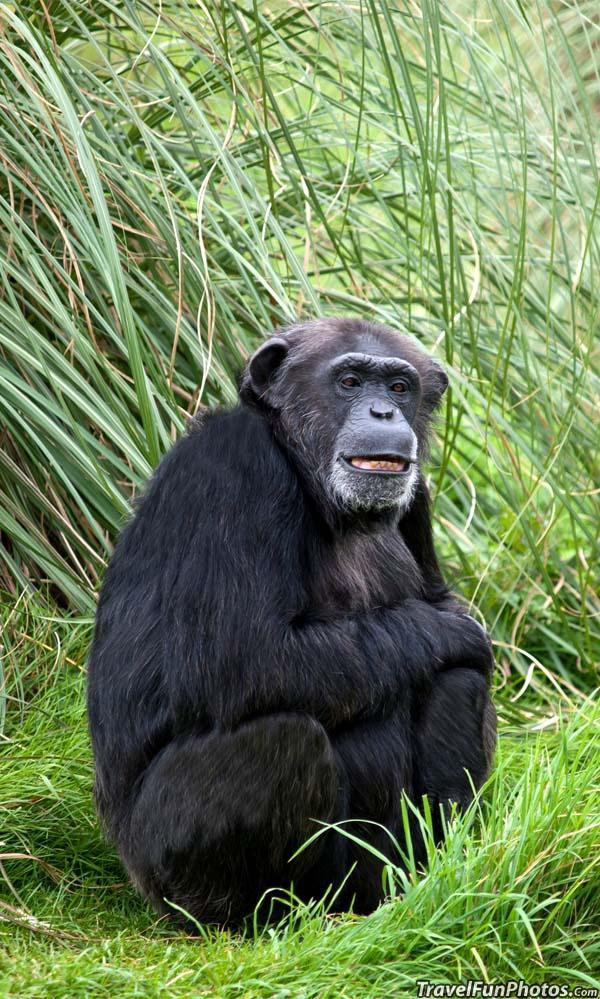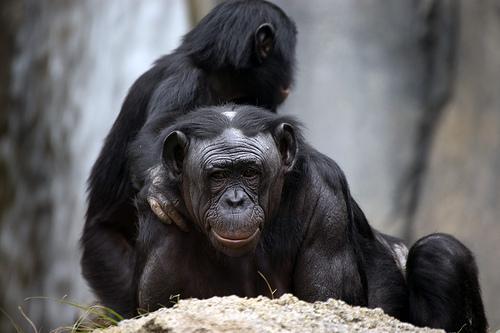The first image is the image on the left, the second image is the image on the right. Assess this claim about the two images: "There are four apes". Correct or not? Answer yes or no. No. 